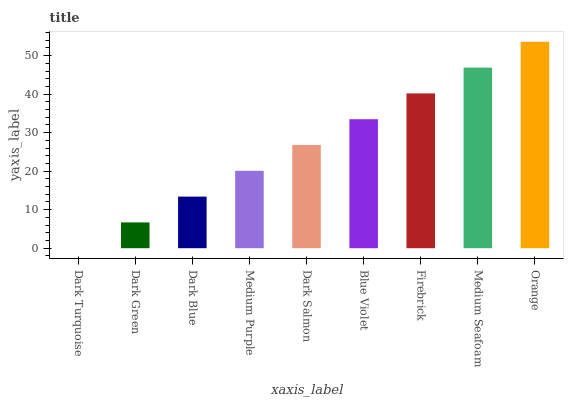Is Dark Turquoise the minimum?
Answer yes or no. Yes. Is Orange the maximum?
Answer yes or no. Yes. Is Dark Green the minimum?
Answer yes or no. No. Is Dark Green the maximum?
Answer yes or no. No. Is Dark Green greater than Dark Turquoise?
Answer yes or no. Yes. Is Dark Turquoise less than Dark Green?
Answer yes or no. Yes. Is Dark Turquoise greater than Dark Green?
Answer yes or no. No. Is Dark Green less than Dark Turquoise?
Answer yes or no. No. Is Dark Salmon the high median?
Answer yes or no. Yes. Is Dark Salmon the low median?
Answer yes or no. Yes. Is Firebrick the high median?
Answer yes or no. No. Is Firebrick the low median?
Answer yes or no. No. 